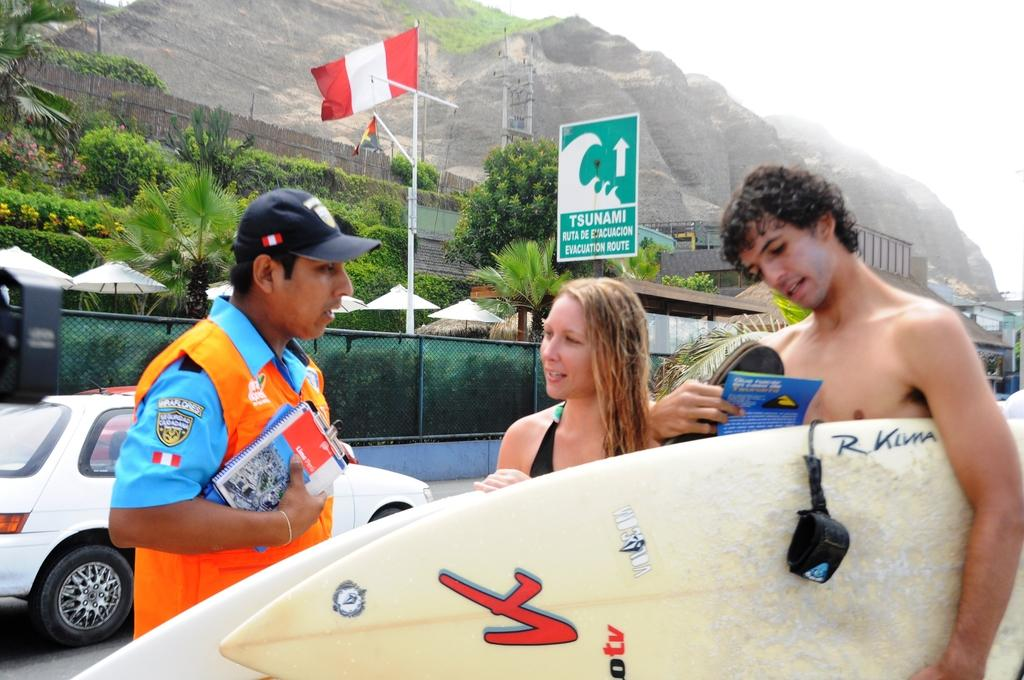How many people are present in the image? There are three persons standing in the image. What else can be seen in the image besides the people? There is a vehicle, a flag, a tree plant, a mountain, and the sky in the image. Can you describe the vehicle in the image? The facts provided do not give specific details about the vehicle. What is the color of the sky in the image? The sky is white in color. How many snails are crawling on the tree plant in the image? There is no mention of snails in the image, so we cannot determine their presence or quantity. Is the clam visible on the mountain in the image? There is no mention of a clam in the image, so we cannot determine its presence. 